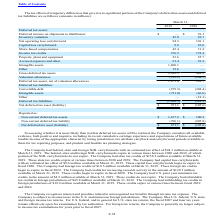From Microchip Technology's financial document, Which years does the table provide information for the tax effects of temporary differences that give rise to significant portions of the Company's deferred tax assets and deferred tax liabilities? The document shows two values: 2019 and 2018. From the document: "2019 2018 2019 2018..." Also, What was the inventory valuation in 2018? According to the financial document, 10.7 (in millions). The relevant text states: "Inventory valuation 45.0 10.7..." Also, What was the amount of convertible debt in 2019? According to the financial document, (279.3) (in millions). The relevant text states: "Convertible debt (279.3) (304.4)..." Also, can you calculate: What was the change in Deferred tax assets, net of valuation allowances between 2018 and 2019? Based on the calculation: 1,971.4-283.7, the result is 1687.7 (in millions). This is based on the information: "Deferred tax assets, net of valuation allowances 1,971.4 283.7 d tax assets, net of valuation allowances 1,971.4 283.7..." The key data points involved are: 1,971.4, 283.7. Also, can you calculate: What was the change in Net operating loss carryforward between 2018 and 2019? Based on the calculation: 94.3-101.1, the result is -6.8 (in millions). This is based on the information: "Net operating loss carryforward 94.3 101.1 Net operating loss carryforward 94.3 101.1..." The key data points involved are: 101.1, 94.3. Also, can you calculate: What was the percentage change in the Net deferred tax asset between 2018 and 2019? To answer this question, I need to perform calculations using the financial data. The calculation is: (971.1-(-105.6))/-105.6, which equals -1019.6 (percentage). This is based on the information: "Net deferred tax asset (liability) $ 971.1 $ (105.6) Net deferred tax asset (liability) $ 971.1 $ (105.6)..." The key data points involved are: 105.6, 971.1. 